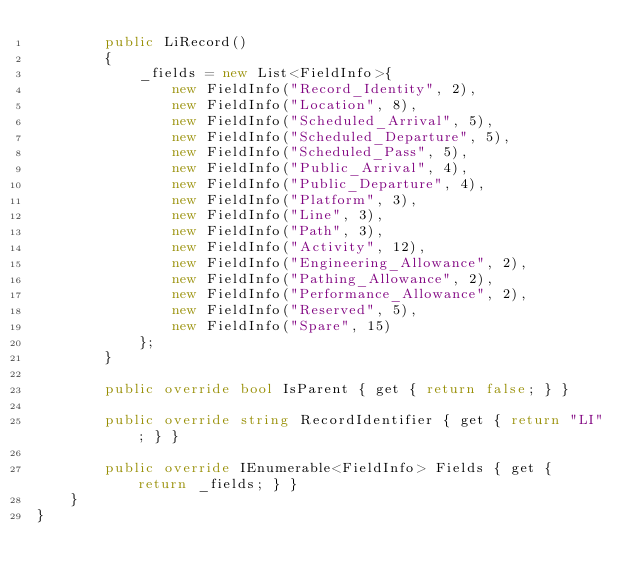<code> <loc_0><loc_0><loc_500><loc_500><_C#_>        public LiRecord()
        {
            _fields = new List<FieldInfo>{
                new FieldInfo("Record_Identity", 2),
                new FieldInfo("Location", 8),
                new FieldInfo("Scheduled_Arrival", 5),
                new FieldInfo("Scheduled_Departure", 5),
                new FieldInfo("Scheduled_Pass", 5),
                new FieldInfo("Public_Arrival", 4),
                new FieldInfo("Public_Departure", 4),
                new FieldInfo("Platform", 3),
                new FieldInfo("Line", 3),
                new FieldInfo("Path", 3),
                new FieldInfo("Activity", 12),
                new FieldInfo("Engineering_Allowance", 2),
                new FieldInfo("Pathing_Allowance", 2),
                new FieldInfo("Performance_Allowance", 2),
                new FieldInfo("Reserved", 5),
                new FieldInfo("Spare", 15)
            };
        }

        public override bool IsParent { get { return false; } }

        public override string RecordIdentifier { get { return "LI"; } }

        public override IEnumerable<FieldInfo> Fields { get { return _fields; } }
    }
}</code> 